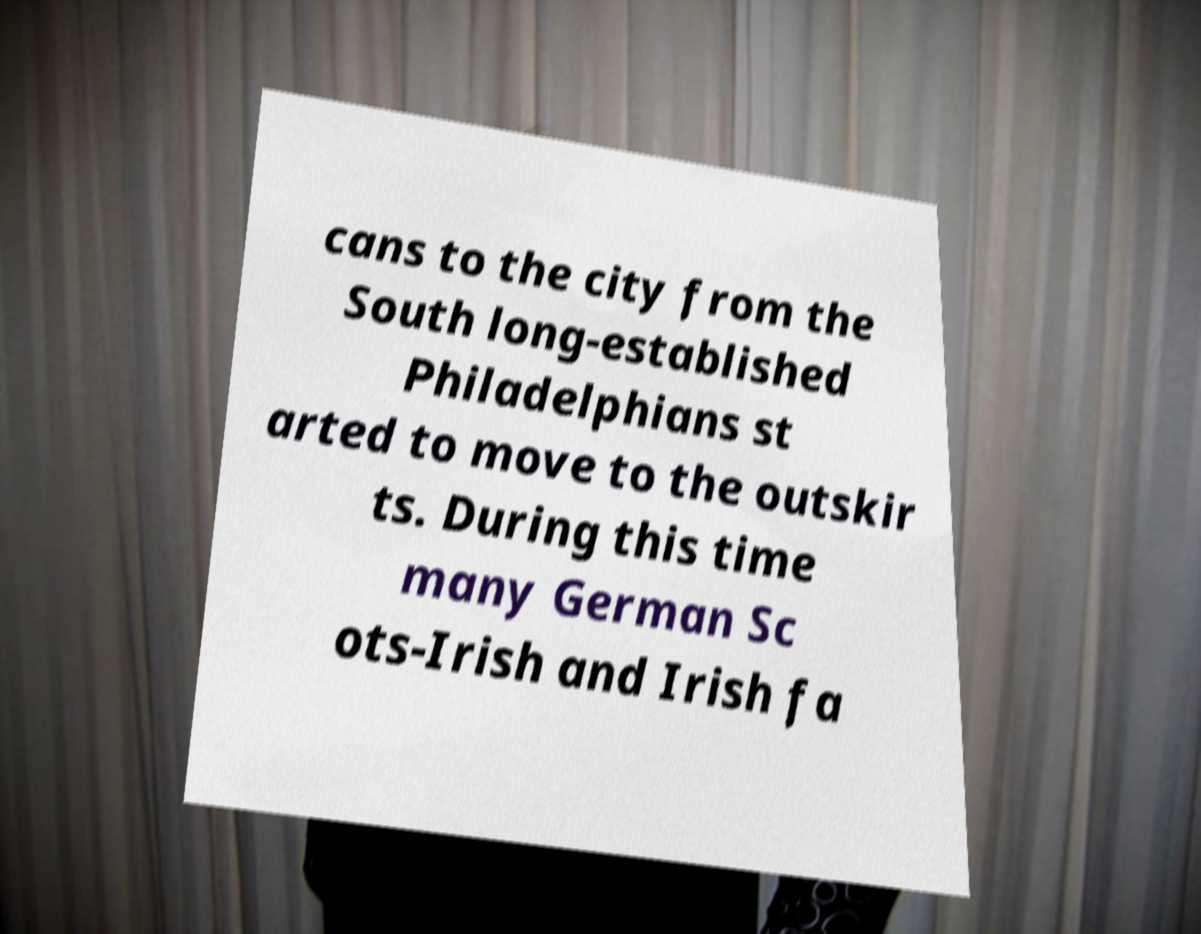Could you extract and type out the text from this image? cans to the city from the South long-established Philadelphians st arted to move to the outskir ts. During this time many German Sc ots-Irish and Irish fa 